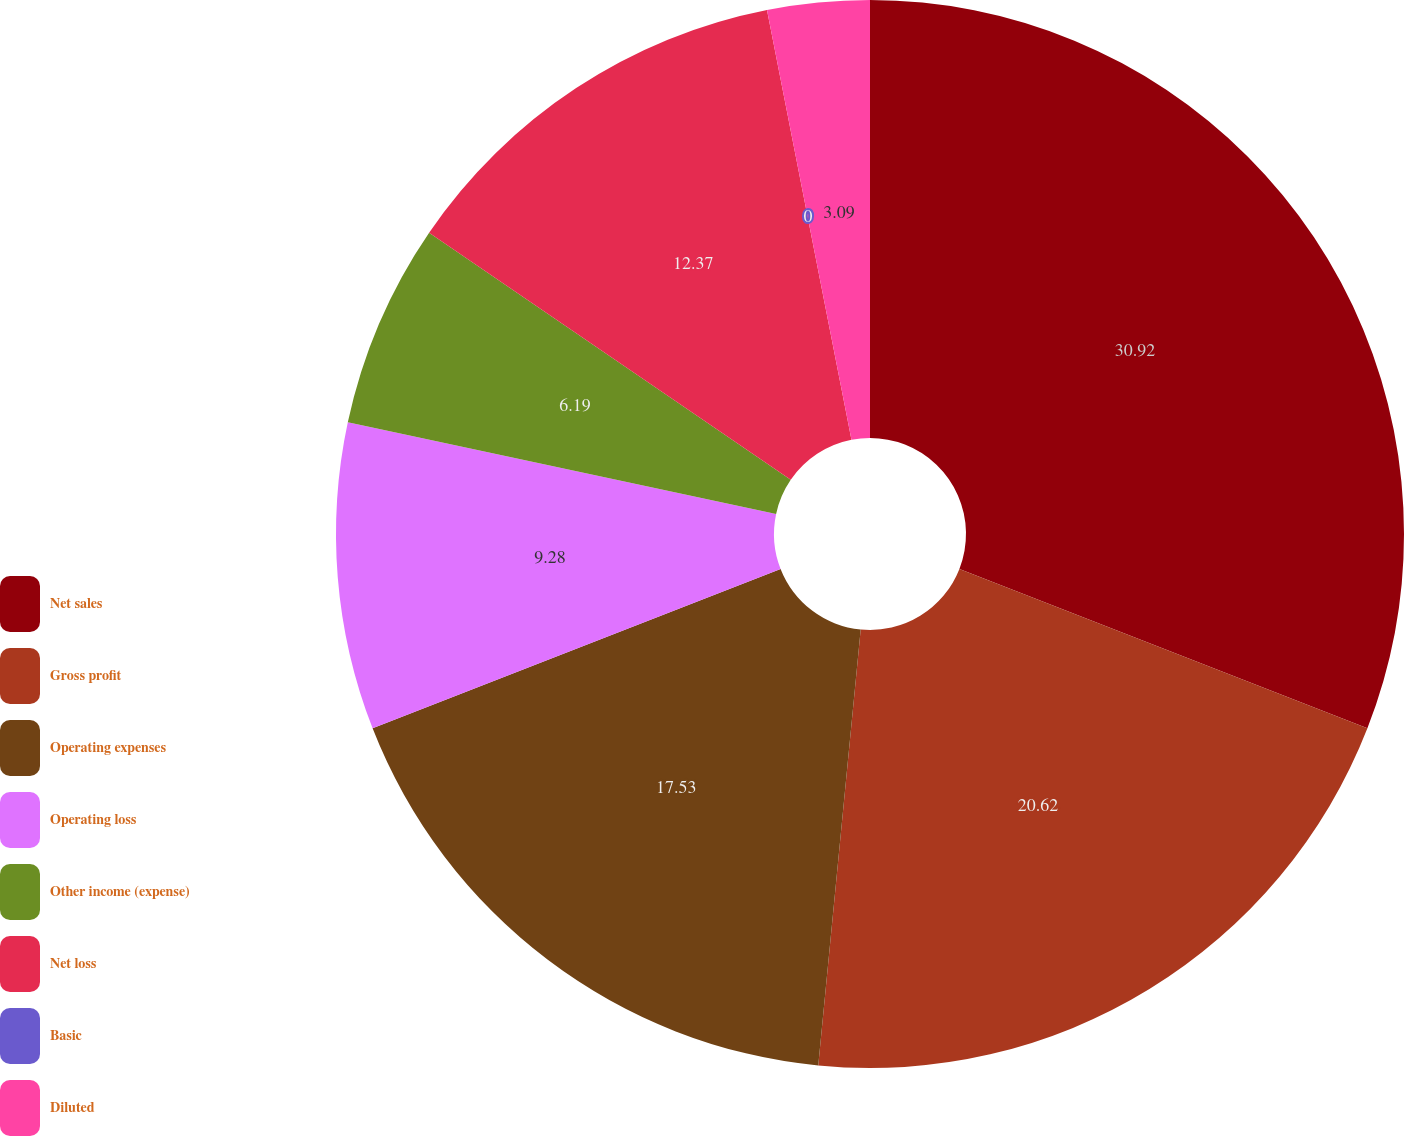Convert chart to OTSL. <chart><loc_0><loc_0><loc_500><loc_500><pie_chart><fcel>Net sales<fcel>Gross profit<fcel>Operating expenses<fcel>Operating loss<fcel>Other income (expense)<fcel>Net loss<fcel>Basic<fcel>Diluted<nl><fcel>30.93%<fcel>20.62%<fcel>17.53%<fcel>9.28%<fcel>6.19%<fcel>12.37%<fcel>0.0%<fcel>3.09%<nl></chart> 